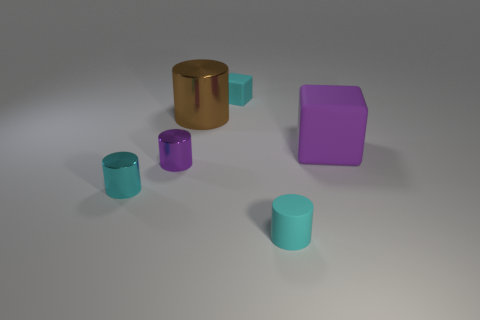Subtract 1 cylinders. How many cylinders are left? 3 Subtract all red cylinders. Subtract all brown balls. How many cylinders are left? 4 Add 1 metal cylinders. How many objects exist? 7 Subtract all cylinders. How many objects are left? 2 Subtract 0 gray cylinders. How many objects are left? 6 Subtract all big red metallic things. Subtract all purple things. How many objects are left? 4 Add 4 big brown cylinders. How many big brown cylinders are left? 5 Add 2 small purple metallic objects. How many small purple metallic objects exist? 3 